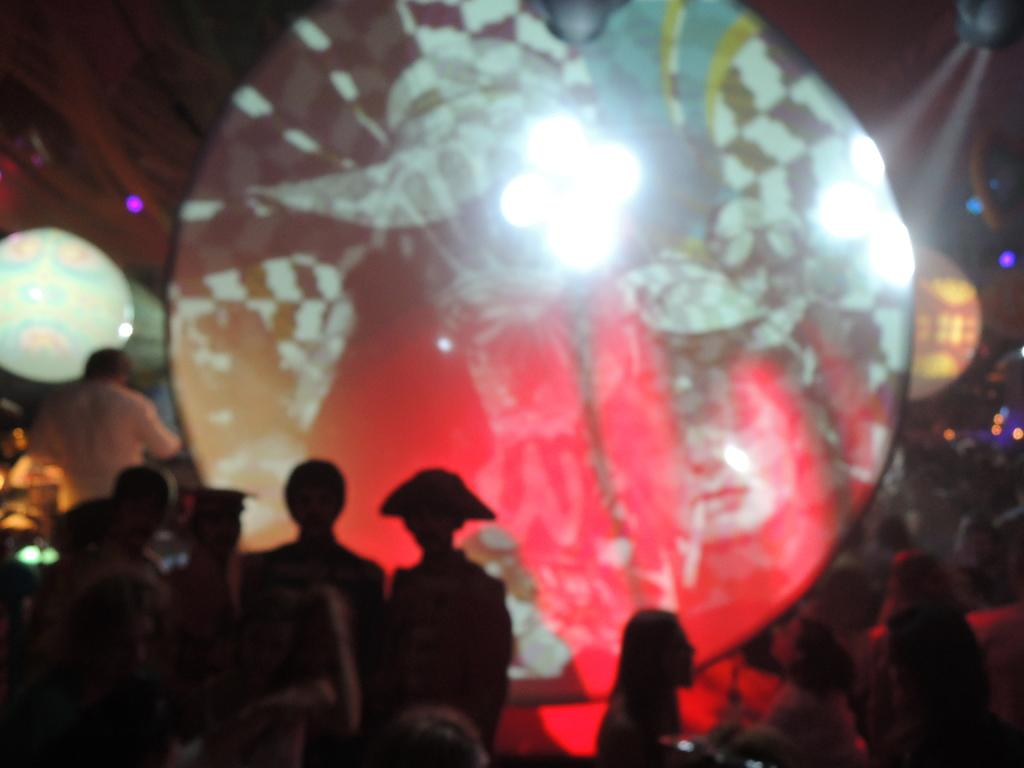What is the main subject of the image? There is a crowd on the floor in the image. What can be seen in the background of the image? There are lights visible in the background of the image. Where might this image have been taken? The image may have been taken in a hall. What time of day might the image have been taken? The image may have been taken during nighttime. What type of insect can be seen wearing a crown in the image? There are no insects or crowns present in the image. How many robins can be seen in the image? There are no robins present in the image. 